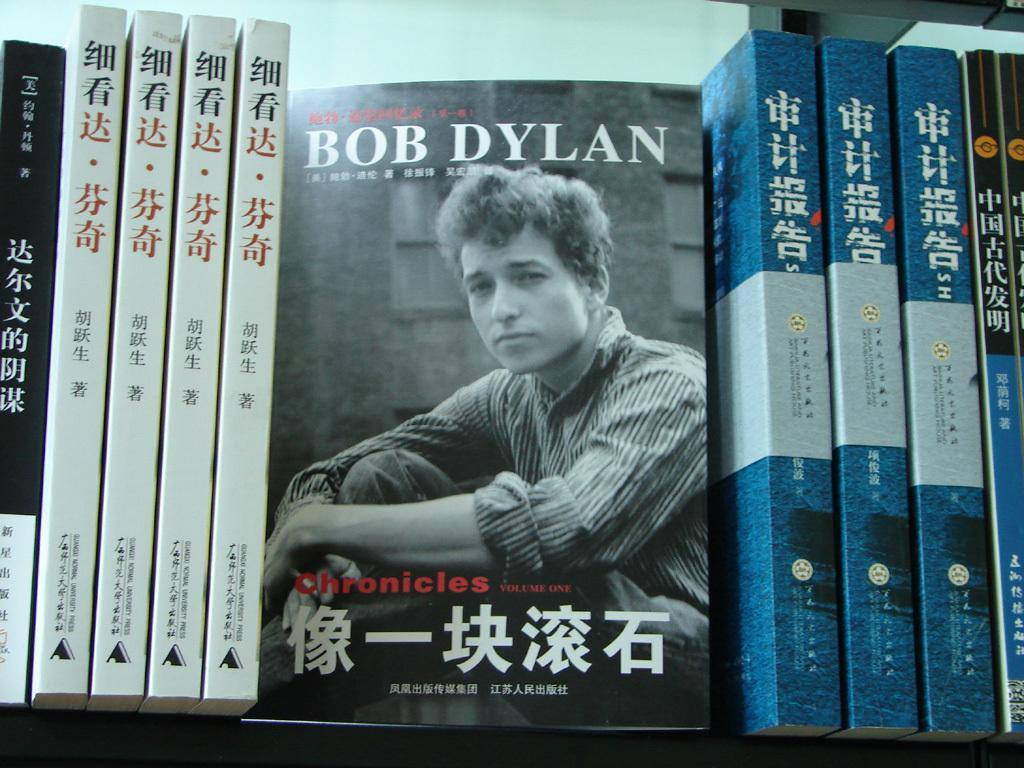<image>
Render a clear and concise summary of the photo. A line of books in a Chinese bookstore where the book facing the viewer is about Bob Dylan. 